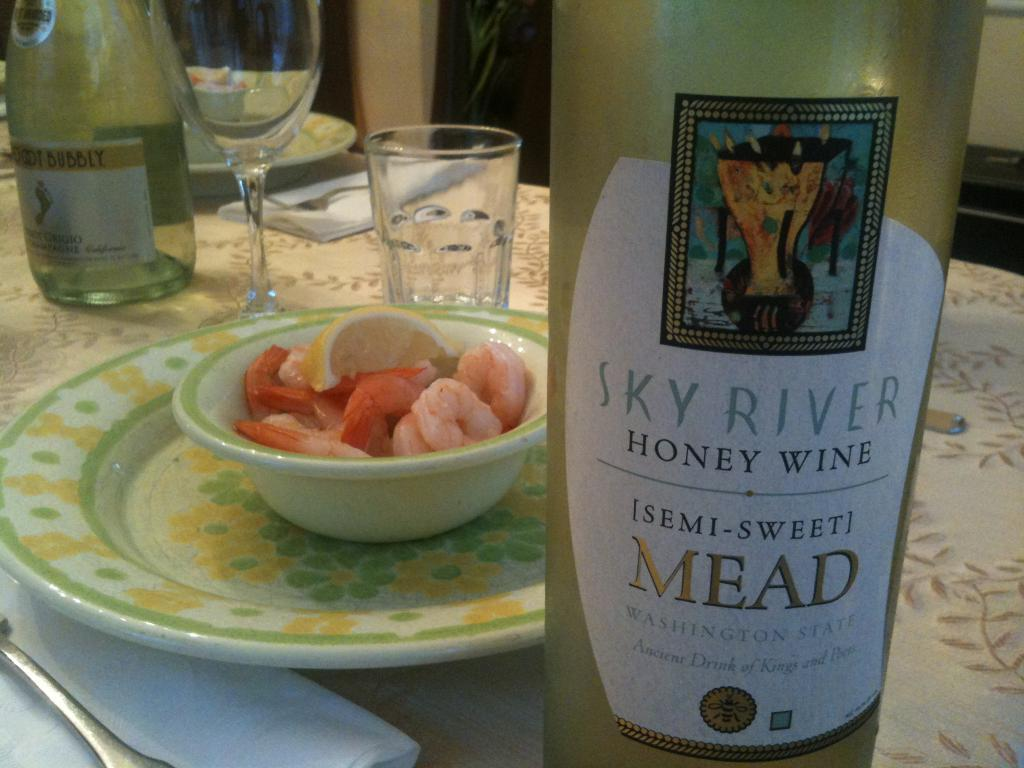<image>
Present a compact description of the photo's key features. The diners chose Sky River Honey Wine, Semi-sweet Mead to pair with their shrimp. 